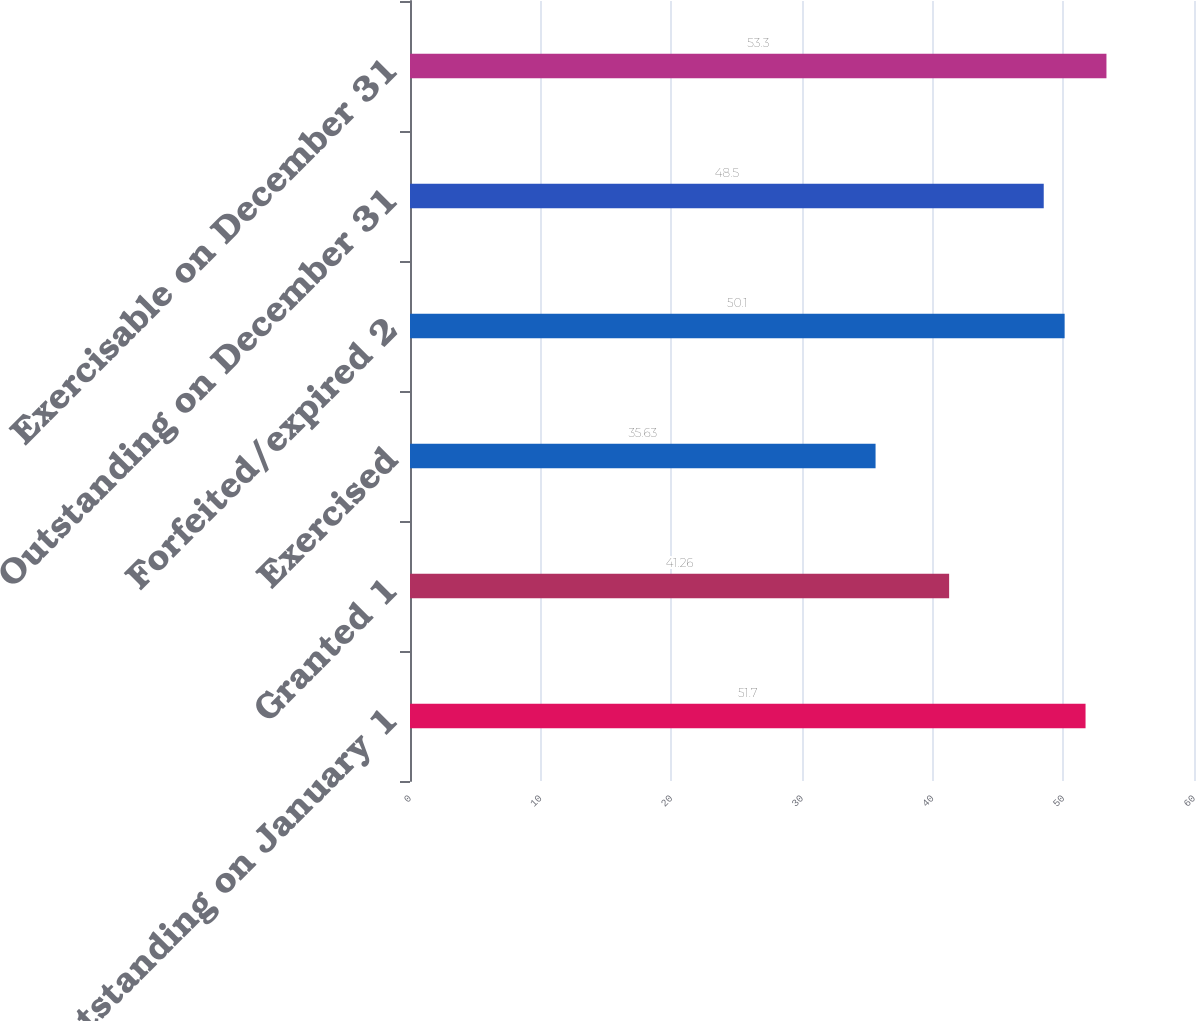Convert chart. <chart><loc_0><loc_0><loc_500><loc_500><bar_chart><fcel>Outstanding on January 1<fcel>Granted 1<fcel>Exercised<fcel>Forfeited/expired 2<fcel>Outstanding on December 31<fcel>Exercisable on December 31<nl><fcel>51.7<fcel>41.26<fcel>35.63<fcel>50.1<fcel>48.5<fcel>53.3<nl></chart> 